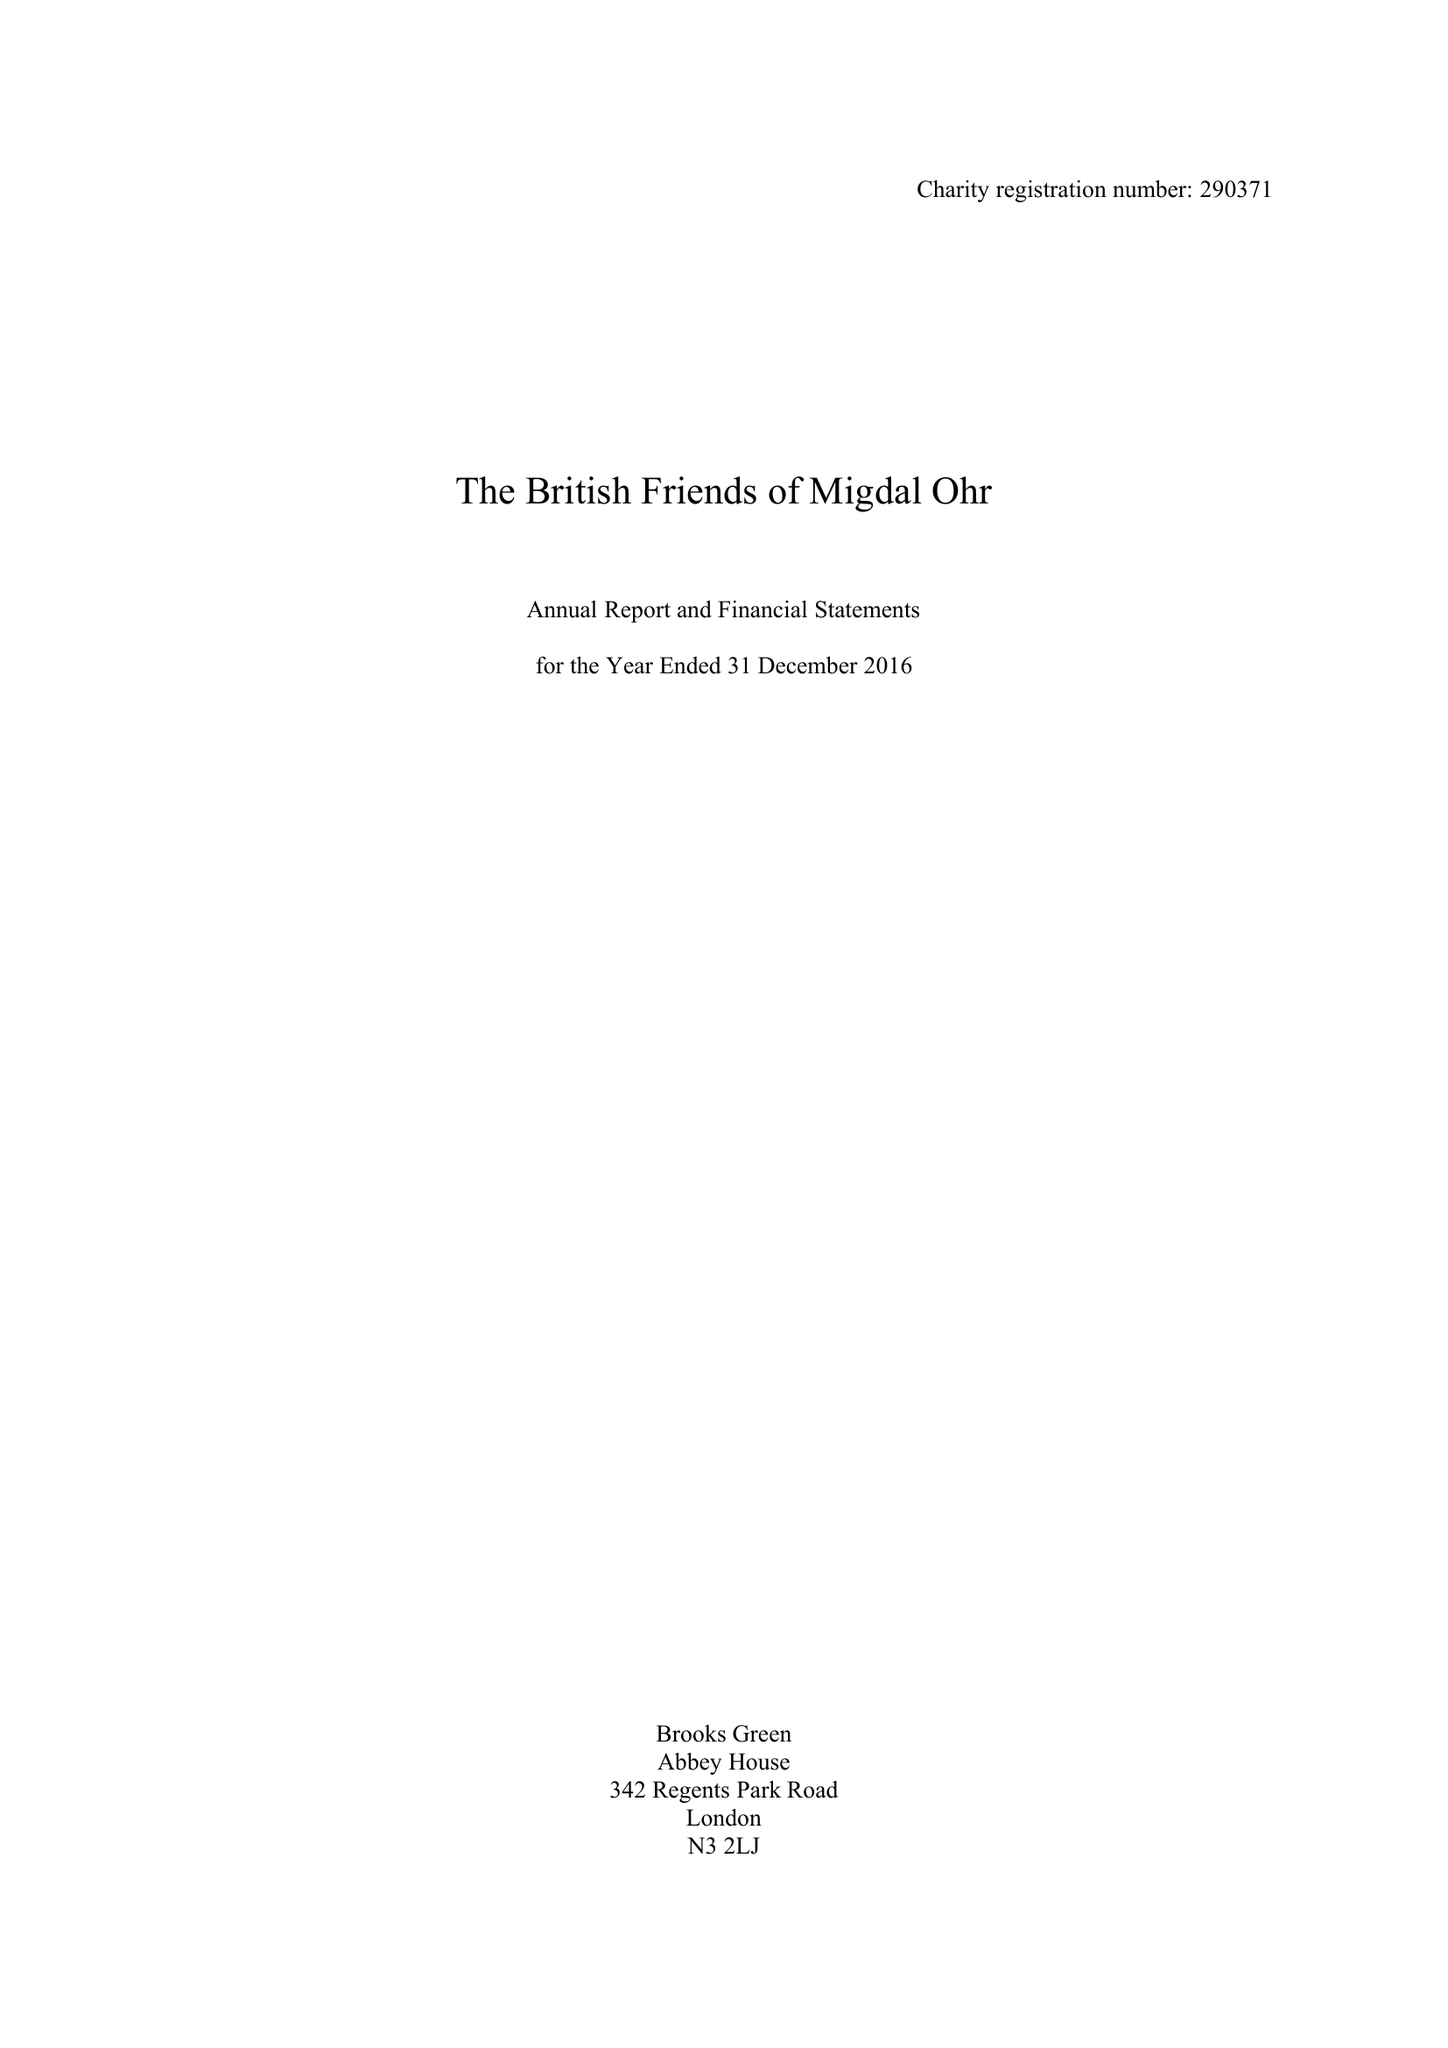What is the value for the charity_name?
Answer the question using a single word or phrase. The British Friends Of Migdal Ohr 